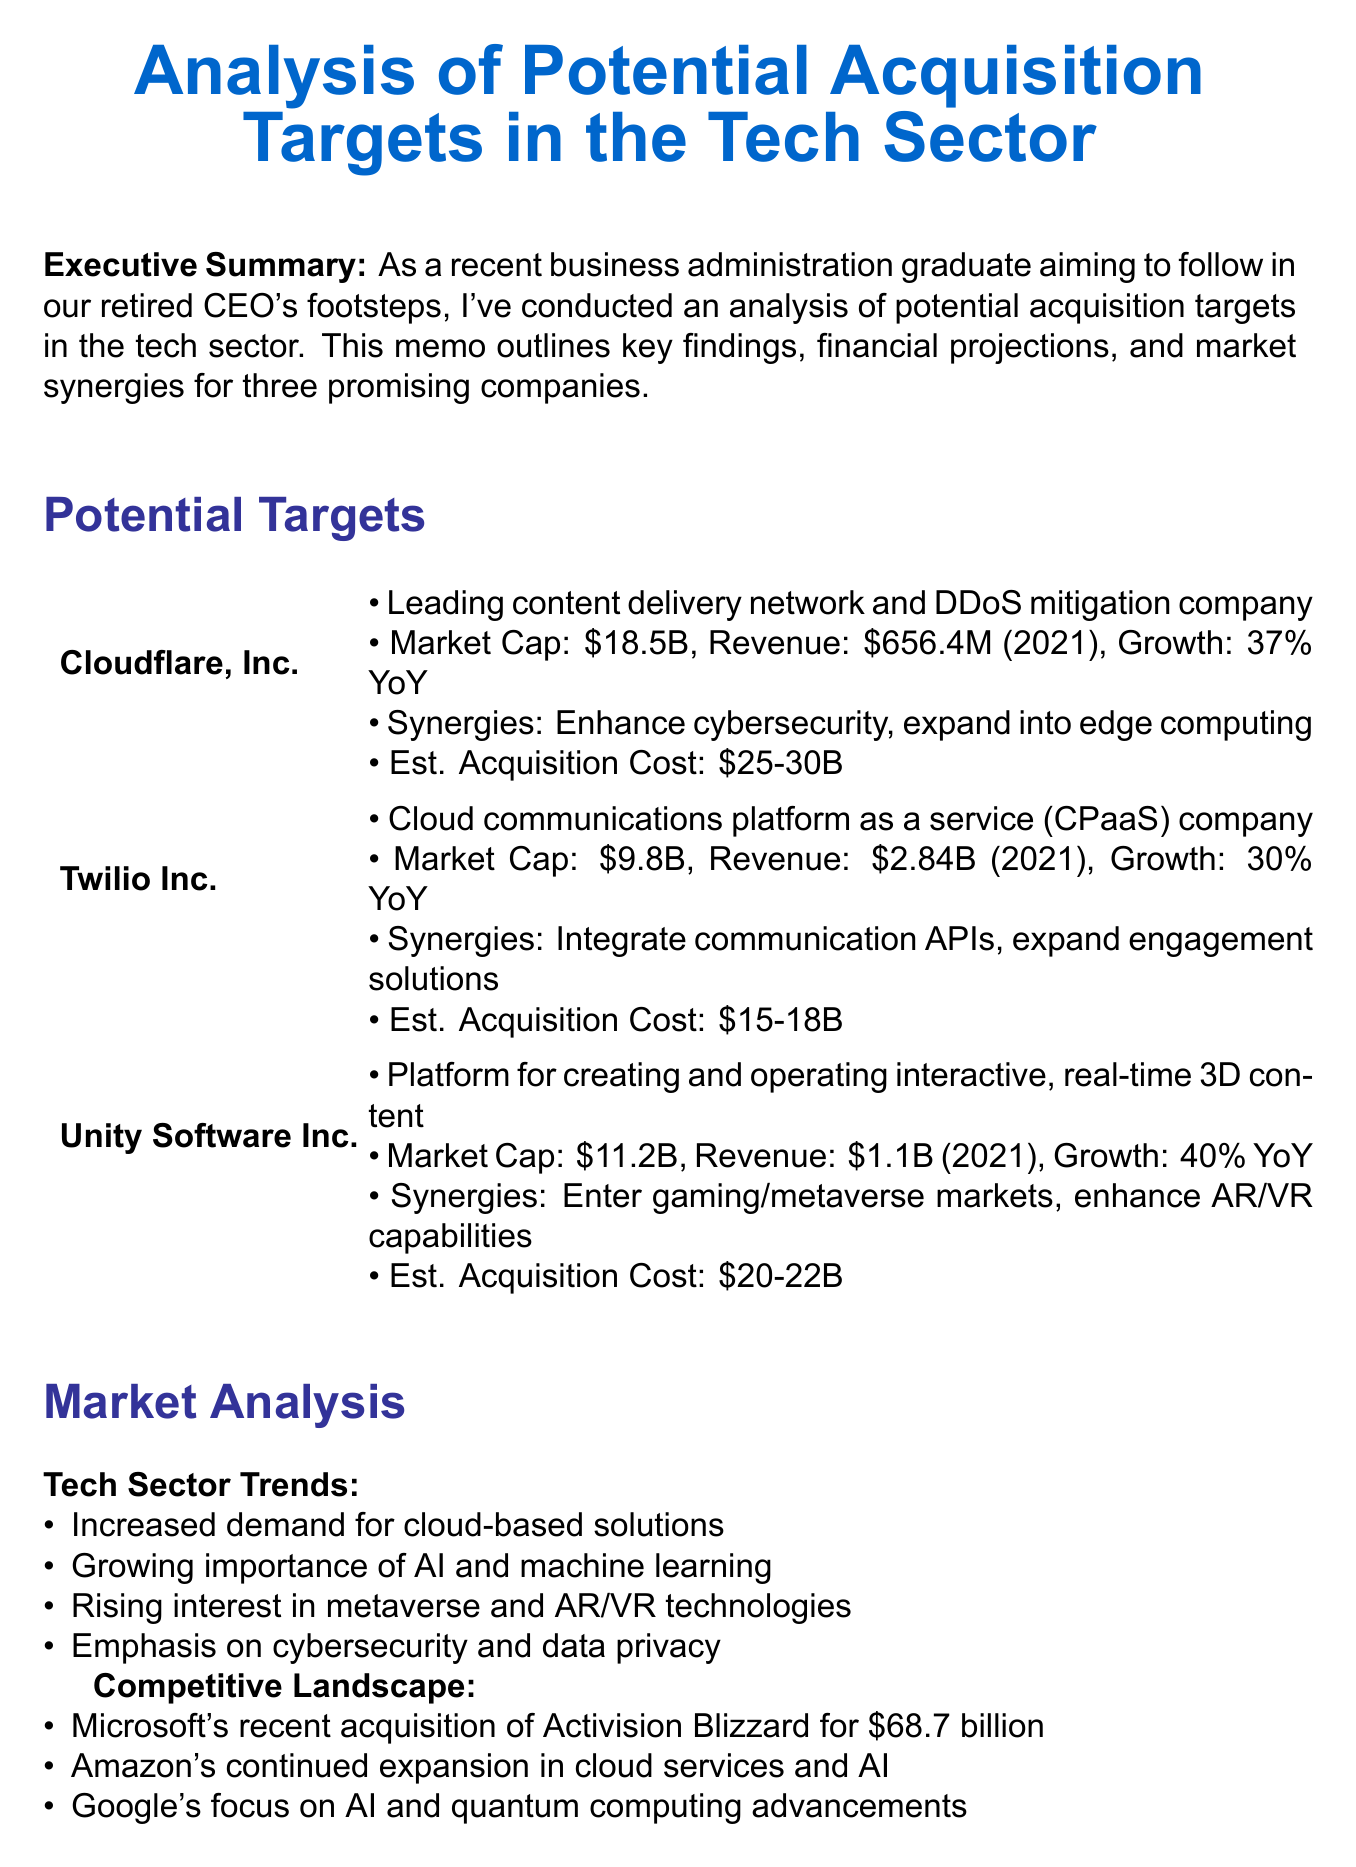what is the title of the memo? The title is stated at the very beginning of the document.
Answer: Analysis of Potential Acquisition Targets in the Tech Sector what is Cloudflare's current market cap? This figure is provided in the financials of the potential targets section.
Answer: $18.5 billion what is the projected growth rate for Unity Software Inc.? The growth rate is explicitly mentioned in the financials of Unity Software.
Answer: 40% YoY what is the estimated acquisition cost for Twilio Inc.? The estimated cost is detailed in the potential targets section of the memo.
Answer: $15-18 billion what is a key synergy identified for Cloudflare, Inc.? This information is listed among the synergies for each target company.
Answer: Enhance our cybersecurity offerings which funding option is among those listed? Funding options are explicitly listed under financial considerations in the memo.
Answer: Cash reserves what is one potential risk mentioned in the memo? The risks are enumerated under financial considerations, providing specific challenges.
Answer: Integration challenges what is the recommended next step? The next steps are outlined at the end of the document.
Answer: Conduct in-depth due diligence on top candidates who made a recent acquisition for $68.7 billion? This information appears in the competitive landscape part of the market analysis.
Answer: Microsoft 